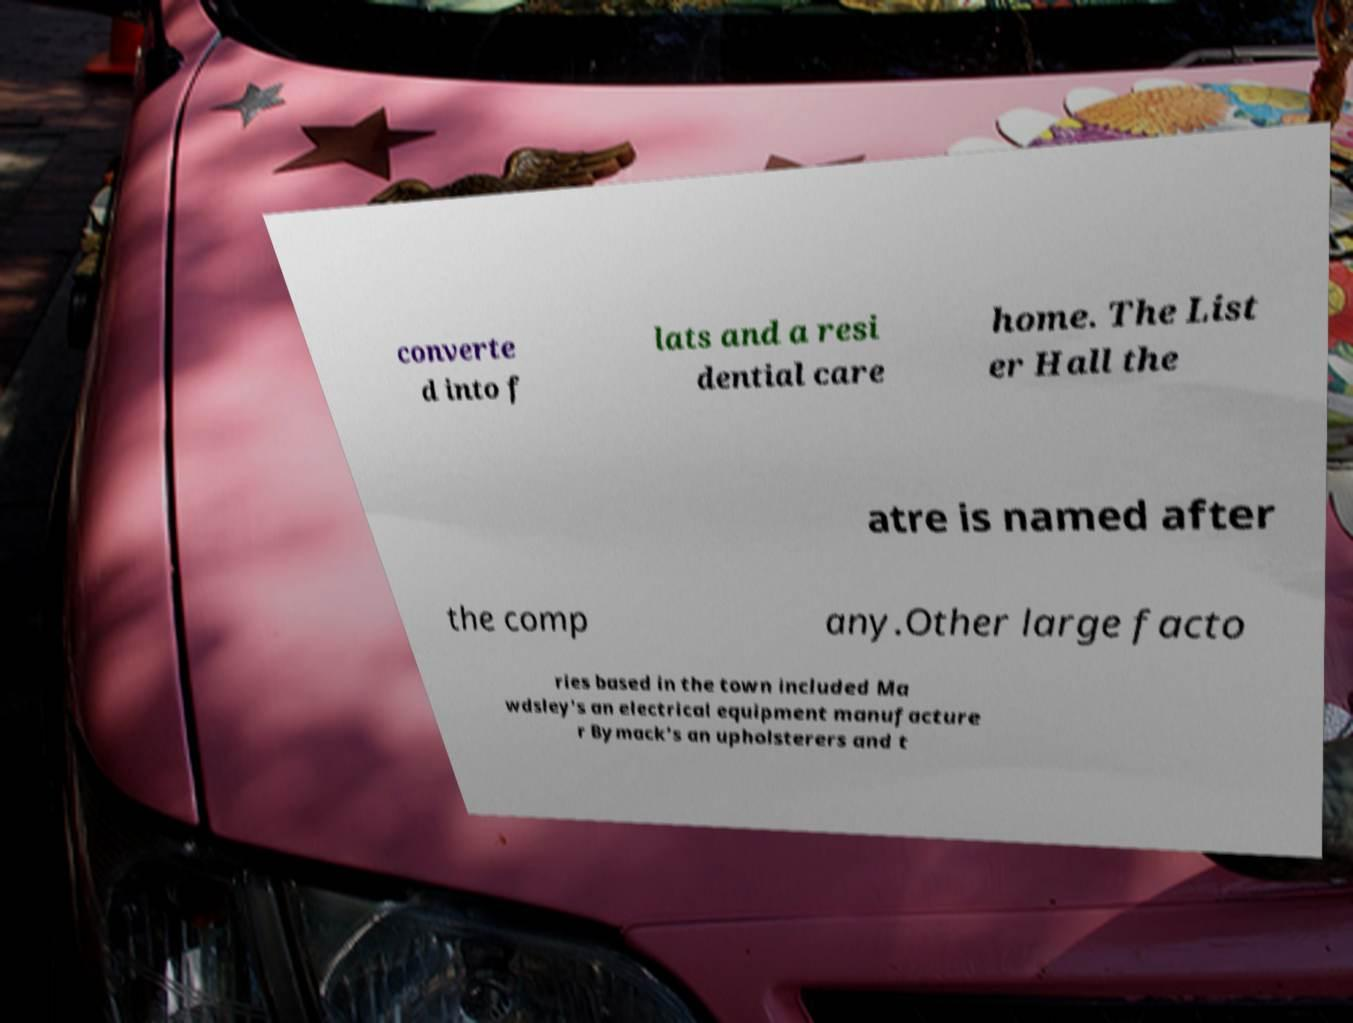Could you assist in decoding the text presented in this image and type it out clearly? converte d into f lats and a resi dential care home. The List er Hall the atre is named after the comp any.Other large facto ries based in the town included Ma wdsley's an electrical equipment manufacture r Bymack's an upholsterers and t 